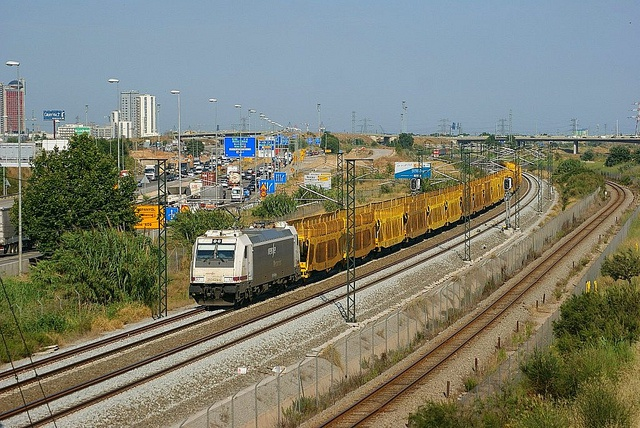Describe the objects in this image and their specific colors. I can see train in darkgray, black, olive, and gray tones, car in darkgray, gray, black, darkblue, and purple tones, car in darkgray, black, gray, and blue tones, car in darkgray, gray, black, lightblue, and blue tones, and car in darkgray, black, and gray tones in this image. 